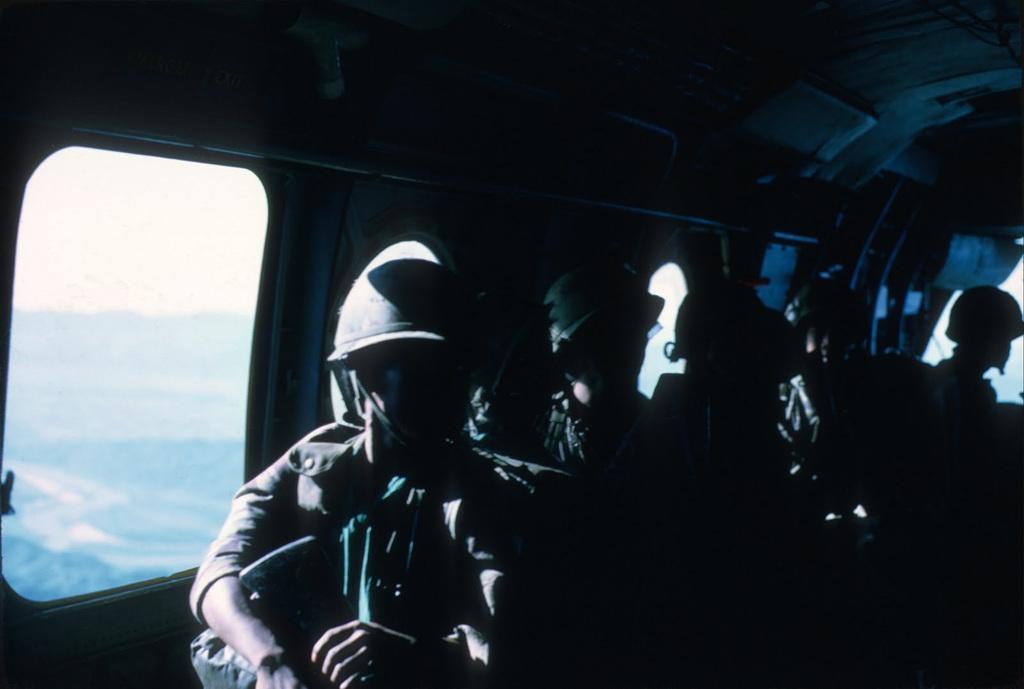Describe this image in one or two sentences. In this image we can see a group of people wearing dress and helmet are sitting inside a vehicle. In the background, we can see the sky. 